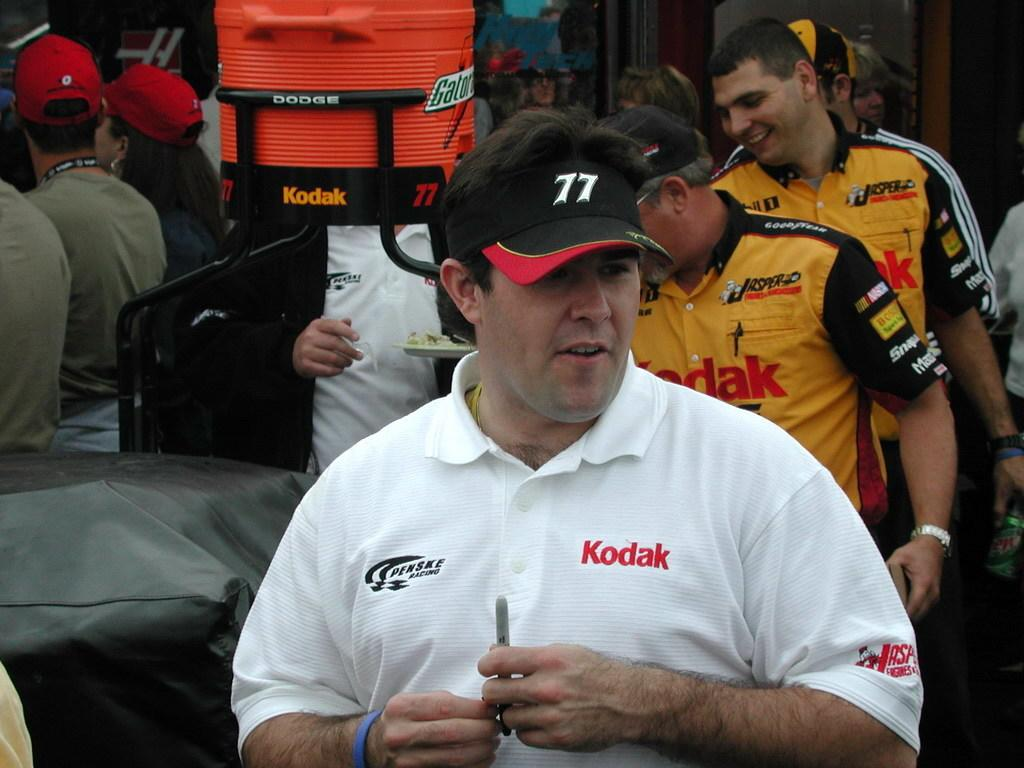Provide a one-sentence caption for the provided image. Men are standing near a gatorade cooler and smiling. 